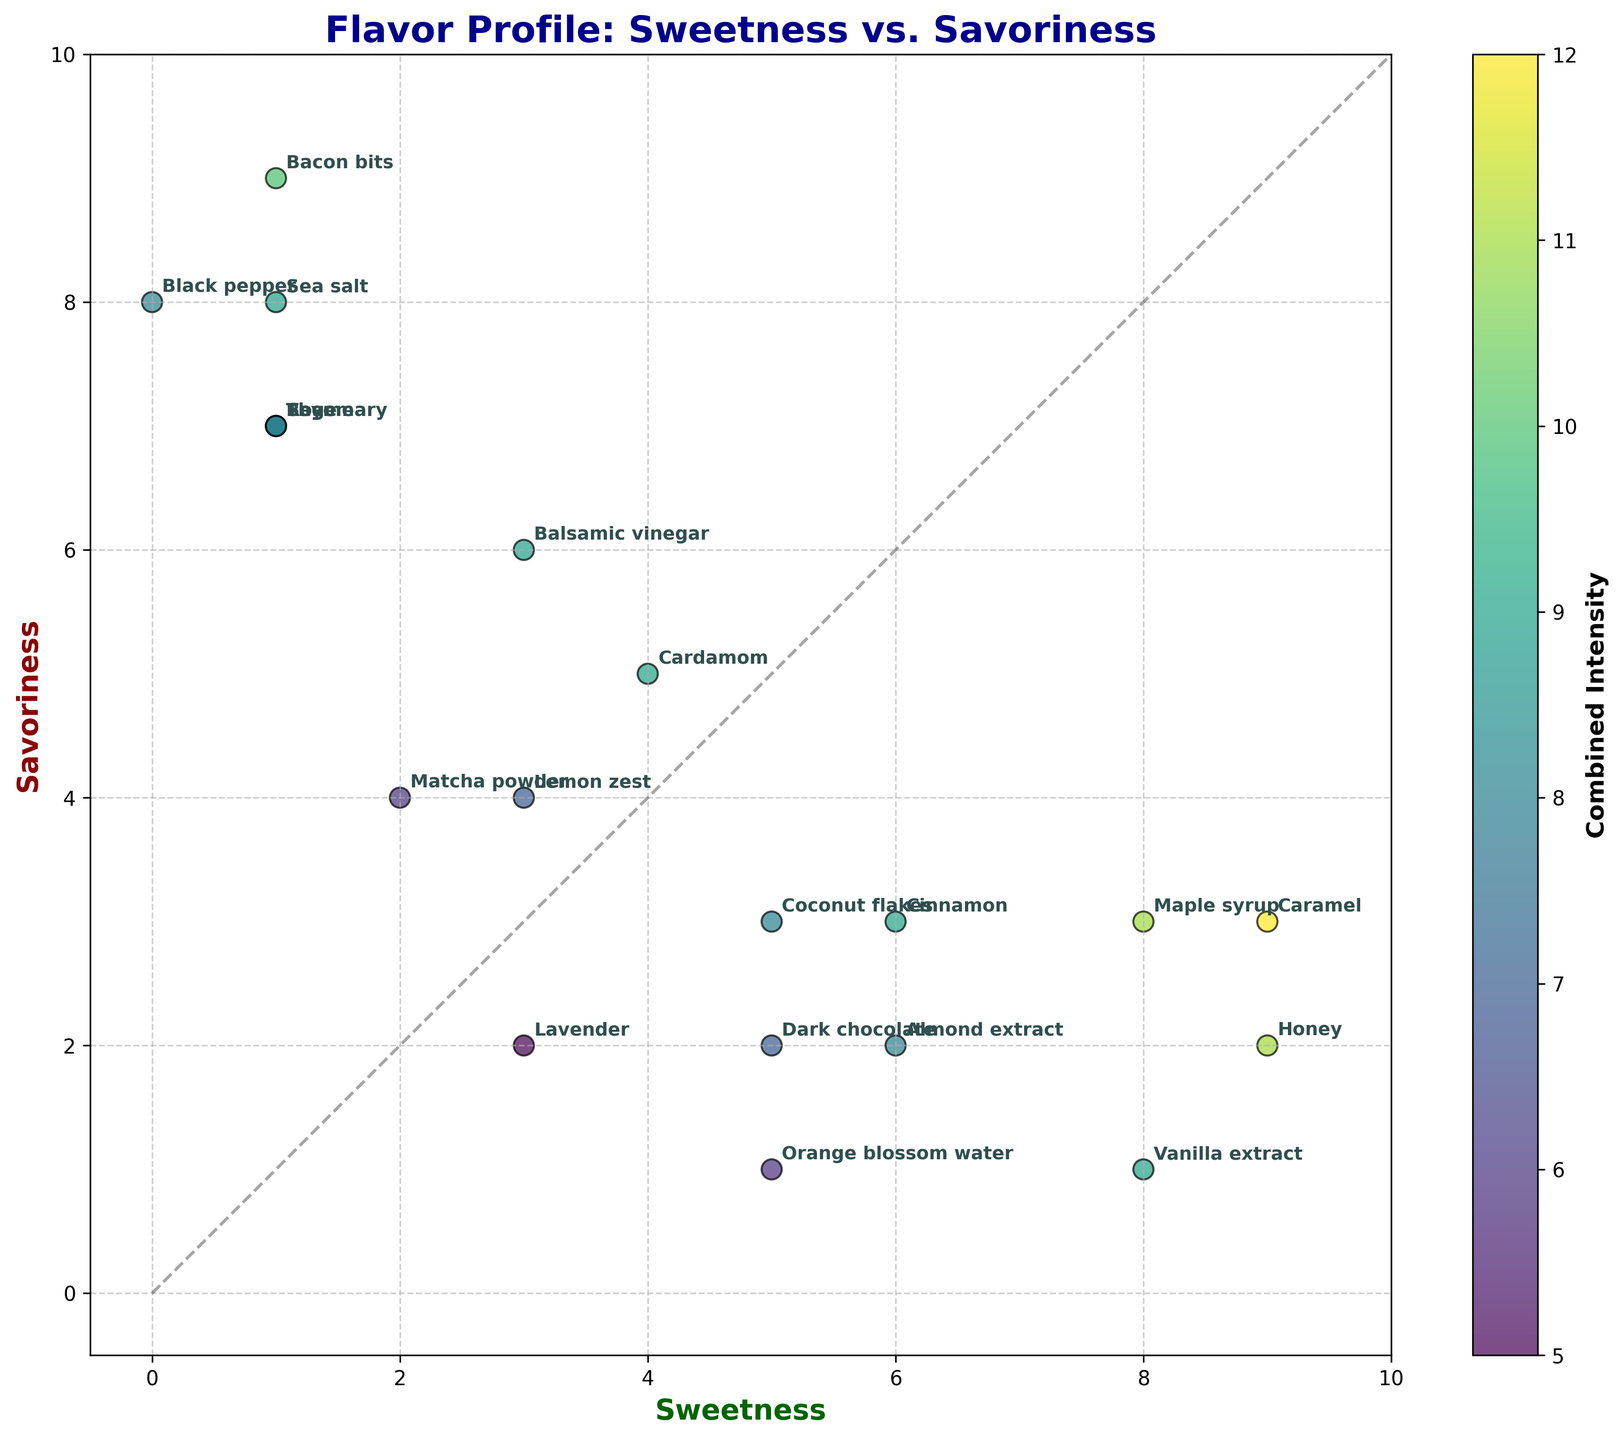What's the title of the plot? The title of the plot is displayed at the top-center of the plot, which is a common location for plot titles.
Answer: Flavor Profile: Sweetness vs. Savoriness How many ingredients have a sweetness value of 9? Look for data points on the plot where the sweetness value is 9, and count the associated ingredient labels.
Answer: 3 What are the sweetness and savoriness values of Sea salt? Locate the label "Sea salt" on the plot and note its position on the x-axis (Sweetness) and y-axis (Savoriness).
Answer: 1 and 8 Which ingredient is the farthest from the diagonal line? Identify the data point most distant from the diagonal line that stretches from the bottom-left to top-right. This can be done by visually assessing the scatter plot.
Answer: Bacon bits Which ingredient has the highest combined intensity of Sweetness and Savoriness? Look at the color intensity represented by the color bar, which indicates combined intensity. The ingredient with the darkest color has the highest combined intensity.
Answer: Bacon bits How do the sweetness and savoriness values of Honey and Maple syrup compare? Locate both ingredients on the plot and compare their sweetness and savoriness values, focusing on their positions on the x-axis and y-axis.
Answer: Both have Sweetness value of 9 and 8 respectively, and Savoriness values of 2 and 3 respectively What is the average sweetness of the ingredients with savoriness values of 7? Identify the ingredients with a savoriness value of 7. Add their sweetness values and divide by the number of those ingredients. Ingredients: Rosemary (1), Sage (1), Thyme (1). The sum of sweetness values is 1+1+1=3. The number of ingredients is 3. So, the average sweetness is 3/3 = 1.
Answer: 1 Which ingredient is both sweet and savory with almost equal intensity? Look for data points near the diagonal line where sweetness and savory values are close to each other. Cardamom has a Sweetness value of 4 and Savoriness value of 5, which are close to each other.
Answer: Cardamom 